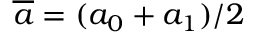Convert formula to latex. <formula><loc_0><loc_0><loc_500><loc_500>\overline { a } = ( a _ { 0 } + a _ { 1 } ) / 2</formula> 